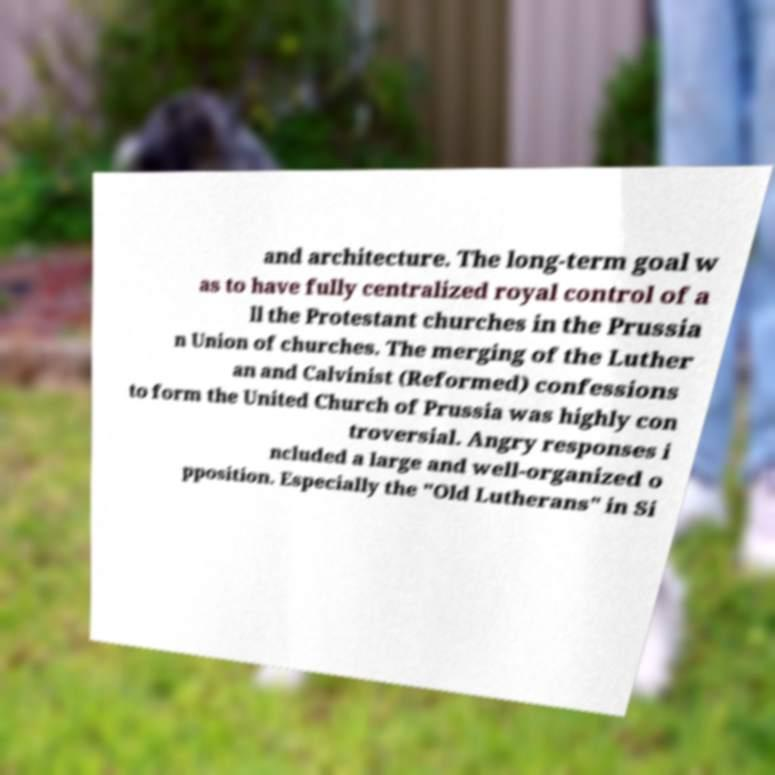Can you accurately transcribe the text from the provided image for me? and architecture. The long-term goal w as to have fully centralized royal control of a ll the Protestant churches in the Prussia n Union of churches. The merging of the Luther an and Calvinist (Reformed) confessions to form the United Church of Prussia was highly con troversial. Angry responses i ncluded a large and well-organized o pposition. Especially the "Old Lutherans" in Si 